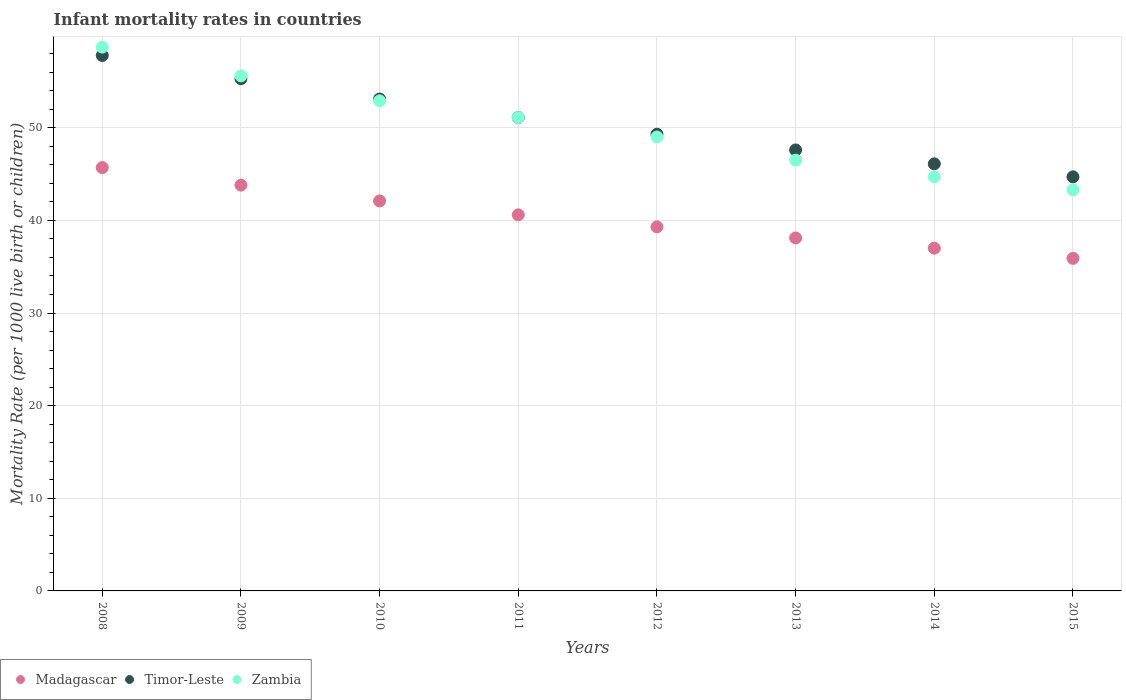How many different coloured dotlines are there?
Keep it short and to the point. 3. Is the number of dotlines equal to the number of legend labels?
Your response must be concise. Yes. What is the infant mortality rate in Timor-Leste in 2012?
Give a very brief answer. 49.3. Across all years, what is the maximum infant mortality rate in Madagascar?
Ensure brevity in your answer.  45.7. Across all years, what is the minimum infant mortality rate in Madagascar?
Offer a terse response. 35.9. In which year was the infant mortality rate in Zambia minimum?
Offer a very short reply. 2015. What is the total infant mortality rate in Timor-Leste in the graph?
Your response must be concise. 405. What is the difference between the infant mortality rate in Zambia in 2012 and that in 2015?
Your answer should be very brief. 5.7. What is the difference between the infant mortality rate in Timor-Leste in 2010 and the infant mortality rate in Madagascar in 2012?
Make the answer very short. 13.8. What is the average infant mortality rate in Zambia per year?
Your answer should be very brief. 50.23. In the year 2010, what is the difference between the infant mortality rate in Zambia and infant mortality rate in Madagascar?
Your answer should be compact. 10.8. In how many years, is the infant mortality rate in Madagascar greater than 14?
Your answer should be compact. 8. What is the ratio of the infant mortality rate in Zambia in 2011 to that in 2012?
Give a very brief answer. 1.04. Is the infant mortality rate in Timor-Leste in 2013 less than that in 2014?
Your answer should be very brief. No. What is the difference between the highest and the lowest infant mortality rate in Madagascar?
Your response must be concise. 9.8. Is the sum of the infant mortality rate in Madagascar in 2008 and 2009 greater than the maximum infant mortality rate in Zambia across all years?
Keep it short and to the point. Yes. Is it the case that in every year, the sum of the infant mortality rate in Timor-Leste and infant mortality rate in Madagascar  is greater than the infant mortality rate in Zambia?
Offer a very short reply. Yes. Does the infant mortality rate in Timor-Leste monotonically increase over the years?
Your answer should be compact. No. Is the infant mortality rate in Zambia strictly greater than the infant mortality rate in Timor-Leste over the years?
Make the answer very short. No. Is the infant mortality rate in Zambia strictly less than the infant mortality rate in Timor-Leste over the years?
Offer a very short reply. No. How many years are there in the graph?
Make the answer very short. 8. What is the difference between two consecutive major ticks on the Y-axis?
Ensure brevity in your answer.  10. Are the values on the major ticks of Y-axis written in scientific E-notation?
Your answer should be compact. No. Does the graph contain any zero values?
Ensure brevity in your answer.  No. Does the graph contain grids?
Give a very brief answer. Yes. How many legend labels are there?
Offer a very short reply. 3. How are the legend labels stacked?
Keep it short and to the point. Horizontal. What is the title of the graph?
Give a very brief answer. Infant mortality rates in countries. What is the label or title of the X-axis?
Your answer should be compact. Years. What is the label or title of the Y-axis?
Your answer should be very brief. Mortality Rate (per 1000 live birth or children). What is the Mortality Rate (per 1000 live birth or children) in Madagascar in 2008?
Give a very brief answer. 45.7. What is the Mortality Rate (per 1000 live birth or children) in Timor-Leste in 2008?
Your answer should be very brief. 57.8. What is the Mortality Rate (per 1000 live birth or children) in Zambia in 2008?
Offer a very short reply. 58.7. What is the Mortality Rate (per 1000 live birth or children) in Madagascar in 2009?
Provide a short and direct response. 43.8. What is the Mortality Rate (per 1000 live birth or children) of Timor-Leste in 2009?
Your response must be concise. 55.3. What is the Mortality Rate (per 1000 live birth or children) of Zambia in 2009?
Offer a terse response. 55.6. What is the Mortality Rate (per 1000 live birth or children) of Madagascar in 2010?
Ensure brevity in your answer.  42.1. What is the Mortality Rate (per 1000 live birth or children) in Timor-Leste in 2010?
Offer a very short reply. 53.1. What is the Mortality Rate (per 1000 live birth or children) of Zambia in 2010?
Offer a terse response. 52.9. What is the Mortality Rate (per 1000 live birth or children) of Madagascar in 2011?
Make the answer very short. 40.6. What is the Mortality Rate (per 1000 live birth or children) in Timor-Leste in 2011?
Your answer should be very brief. 51.1. What is the Mortality Rate (per 1000 live birth or children) in Zambia in 2011?
Keep it short and to the point. 51.1. What is the Mortality Rate (per 1000 live birth or children) in Madagascar in 2012?
Provide a short and direct response. 39.3. What is the Mortality Rate (per 1000 live birth or children) of Timor-Leste in 2012?
Ensure brevity in your answer.  49.3. What is the Mortality Rate (per 1000 live birth or children) in Madagascar in 2013?
Provide a short and direct response. 38.1. What is the Mortality Rate (per 1000 live birth or children) of Timor-Leste in 2013?
Ensure brevity in your answer.  47.6. What is the Mortality Rate (per 1000 live birth or children) in Zambia in 2013?
Provide a short and direct response. 46.5. What is the Mortality Rate (per 1000 live birth or children) of Madagascar in 2014?
Provide a short and direct response. 37. What is the Mortality Rate (per 1000 live birth or children) of Timor-Leste in 2014?
Ensure brevity in your answer.  46.1. What is the Mortality Rate (per 1000 live birth or children) in Zambia in 2014?
Make the answer very short. 44.7. What is the Mortality Rate (per 1000 live birth or children) in Madagascar in 2015?
Make the answer very short. 35.9. What is the Mortality Rate (per 1000 live birth or children) in Timor-Leste in 2015?
Your answer should be compact. 44.7. What is the Mortality Rate (per 1000 live birth or children) of Zambia in 2015?
Make the answer very short. 43.3. Across all years, what is the maximum Mortality Rate (per 1000 live birth or children) in Madagascar?
Your answer should be compact. 45.7. Across all years, what is the maximum Mortality Rate (per 1000 live birth or children) in Timor-Leste?
Offer a very short reply. 57.8. Across all years, what is the maximum Mortality Rate (per 1000 live birth or children) of Zambia?
Provide a short and direct response. 58.7. Across all years, what is the minimum Mortality Rate (per 1000 live birth or children) of Madagascar?
Offer a terse response. 35.9. Across all years, what is the minimum Mortality Rate (per 1000 live birth or children) in Timor-Leste?
Your answer should be compact. 44.7. Across all years, what is the minimum Mortality Rate (per 1000 live birth or children) of Zambia?
Your answer should be very brief. 43.3. What is the total Mortality Rate (per 1000 live birth or children) in Madagascar in the graph?
Give a very brief answer. 322.5. What is the total Mortality Rate (per 1000 live birth or children) in Timor-Leste in the graph?
Offer a very short reply. 405. What is the total Mortality Rate (per 1000 live birth or children) of Zambia in the graph?
Your response must be concise. 401.8. What is the difference between the Mortality Rate (per 1000 live birth or children) of Madagascar in 2008 and that in 2009?
Make the answer very short. 1.9. What is the difference between the Mortality Rate (per 1000 live birth or children) of Timor-Leste in 2008 and that in 2009?
Offer a very short reply. 2.5. What is the difference between the Mortality Rate (per 1000 live birth or children) of Madagascar in 2008 and that in 2010?
Provide a succinct answer. 3.6. What is the difference between the Mortality Rate (per 1000 live birth or children) of Madagascar in 2008 and that in 2013?
Your response must be concise. 7.6. What is the difference between the Mortality Rate (per 1000 live birth or children) of Zambia in 2008 and that in 2014?
Your response must be concise. 14. What is the difference between the Mortality Rate (per 1000 live birth or children) in Madagascar in 2009 and that in 2010?
Your response must be concise. 1.7. What is the difference between the Mortality Rate (per 1000 live birth or children) in Madagascar in 2009 and that in 2011?
Provide a short and direct response. 3.2. What is the difference between the Mortality Rate (per 1000 live birth or children) in Madagascar in 2009 and that in 2012?
Keep it short and to the point. 4.5. What is the difference between the Mortality Rate (per 1000 live birth or children) of Timor-Leste in 2009 and that in 2012?
Make the answer very short. 6. What is the difference between the Mortality Rate (per 1000 live birth or children) in Zambia in 2009 and that in 2013?
Offer a terse response. 9.1. What is the difference between the Mortality Rate (per 1000 live birth or children) in Madagascar in 2009 and that in 2014?
Keep it short and to the point. 6.8. What is the difference between the Mortality Rate (per 1000 live birth or children) in Timor-Leste in 2009 and that in 2014?
Your response must be concise. 9.2. What is the difference between the Mortality Rate (per 1000 live birth or children) of Timor-Leste in 2009 and that in 2015?
Your answer should be compact. 10.6. What is the difference between the Mortality Rate (per 1000 live birth or children) in Zambia in 2009 and that in 2015?
Make the answer very short. 12.3. What is the difference between the Mortality Rate (per 1000 live birth or children) in Zambia in 2010 and that in 2011?
Your response must be concise. 1.8. What is the difference between the Mortality Rate (per 1000 live birth or children) of Madagascar in 2010 and that in 2012?
Offer a terse response. 2.8. What is the difference between the Mortality Rate (per 1000 live birth or children) in Timor-Leste in 2010 and that in 2012?
Provide a short and direct response. 3.8. What is the difference between the Mortality Rate (per 1000 live birth or children) of Zambia in 2010 and that in 2012?
Ensure brevity in your answer.  3.9. What is the difference between the Mortality Rate (per 1000 live birth or children) in Zambia in 2010 and that in 2013?
Your answer should be very brief. 6.4. What is the difference between the Mortality Rate (per 1000 live birth or children) of Madagascar in 2010 and that in 2015?
Give a very brief answer. 6.2. What is the difference between the Mortality Rate (per 1000 live birth or children) in Zambia in 2010 and that in 2015?
Provide a short and direct response. 9.6. What is the difference between the Mortality Rate (per 1000 live birth or children) in Madagascar in 2011 and that in 2012?
Provide a succinct answer. 1.3. What is the difference between the Mortality Rate (per 1000 live birth or children) of Zambia in 2011 and that in 2012?
Provide a short and direct response. 2.1. What is the difference between the Mortality Rate (per 1000 live birth or children) in Timor-Leste in 2011 and that in 2013?
Give a very brief answer. 3.5. What is the difference between the Mortality Rate (per 1000 live birth or children) in Madagascar in 2011 and that in 2014?
Provide a succinct answer. 3.6. What is the difference between the Mortality Rate (per 1000 live birth or children) in Zambia in 2011 and that in 2014?
Your answer should be very brief. 6.4. What is the difference between the Mortality Rate (per 1000 live birth or children) in Madagascar in 2011 and that in 2015?
Your answer should be compact. 4.7. What is the difference between the Mortality Rate (per 1000 live birth or children) of Timor-Leste in 2011 and that in 2015?
Offer a terse response. 6.4. What is the difference between the Mortality Rate (per 1000 live birth or children) of Zambia in 2011 and that in 2015?
Offer a very short reply. 7.8. What is the difference between the Mortality Rate (per 1000 live birth or children) in Zambia in 2012 and that in 2013?
Offer a very short reply. 2.5. What is the difference between the Mortality Rate (per 1000 live birth or children) in Madagascar in 2012 and that in 2014?
Give a very brief answer. 2.3. What is the difference between the Mortality Rate (per 1000 live birth or children) of Timor-Leste in 2012 and that in 2014?
Offer a very short reply. 3.2. What is the difference between the Mortality Rate (per 1000 live birth or children) of Timor-Leste in 2013 and that in 2014?
Provide a short and direct response. 1.5. What is the difference between the Mortality Rate (per 1000 live birth or children) of Timor-Leste in 2013 and that in 2015?
Your response must be concise. 2.9. What is the difference between the Mortality Rate (per 1000 live birth or children) of Zambia in 2013 and that in 2015?
Provide a succinct answer. 3.2. What is the difference between the Mortality Rate (per 1000 live birth or children) in Madagascar in 2014 and that in 2015?
Give a very brief answer. 1.1. What is the difference between the Mortality Rate (per 1000 live birth or children) of Timor-Leste in 2014 and that in 2015?
Keep it short and to the point. 1.4. What is the difference between the Mortality Rate (per 1000 live birth or children) in Zambia in 2014 and that in 2015?
Your answer should be very brief. 1.4. What is the difference between the Mortality Rate (per 1000 live birth or children) of Madagascar in 2008 and the Mortality Rate (per 1000 live birth or children) of Zambia in 2009?
Provide a succinct answer. -9.9. What is the difference between the Mortality Rate (per 1000 live birth or children) of Timor-Leste in 2008 and the Mortality Rate (per 1000 live birth or children) of Zambia in 2009?
Give a very brief answer. 2.2. What is the difference between the Mortality Rate (per 1000 live birth or children) of Madagascar in 2008 and the Mortality Rate (per 1000 live birth or children) of Timor-Leste in 2010?
Give a very brief answer. -7.4. What is the difference between the Mortality Rate (per 1000 live birth or children) in Madagascar in 2008 and the Mortality Rate (per 1000 live birth or children) in Zambia in 2010?
Offer a very short reply. -7.2. What is the difference between the Mortality Rate (per 1000 live birth or children) in Madagascar in 2008 and the Mortality Rate (per 1000 live birth or children) in Timor-Leste in 2011?
Offer a very short reply. -5.4. What is the difference between the Mortality Rate (per 1000 live birth or children) in Timor-Leste in 2008 and the Mortality Rate (per 1000 live birth or children) in Zambia in 2011?
Ensure brevity in your answer.  6.7. What is the difference between the Mortality Rate (per 1000 live birth or children) of Madagascar in 2008 and the Mortality Rate (per 1000 live birth or children) of Zambia in 2012?
Offer a terse response. -3.3. What is the difference between the Mortality Rate (per 1000 live birth or children) of Madagascar in 2008 and the Mortality Rate (per 1000 live birth or children) of Timor-Leste in 2013?
Your answer should be very brief. -1.9. What is the difference between the Mortality Rate (per 1000 live birth or children) in Timor-Leste in 2008 and the Mortality Rate (per 1000 live birth or children) in Zambia in 2013?
Your response must be concise. 11.3. What is the difference between the Mortality Rate (per 1000 live birth or children) in Madagascar in 2008 and the Mortality Rate (per 1000 live birth or children) in Timor-Leste in 2014?
Your answer should be compact. -0.4. What is the difference between the Mortality Rate (per 1000 live birth or children) of Timor-Leste in 2008 and the Mortality Rate (per 1000 live birth or children) of Zambia in 2014?
Your response must be concise. 13.1. What is the difference between the Mortality Rate (per 1000 live birth or children) in Madagascar in 2008 and the Mortality Rate (per 1000 live birth or children) in Zambia in 2015?
Your answer should be compact. 2.4. What is the difference between the Mortality Rate (per 1000 live birth or children) in Madagascar in 2009 and the Mortality Rate (per 1000 live birth or children) in Zambia in 2010?
Make the answer very short. -9.1. What is the difference between the Mortality Rate (per 1000 live birth or children) in Timor-Leste in 2009 and the Mortality Rate (per 1000 live birth or children) in Zambia in 2010?
Give a very brief answer. 2.4. What is the difference between the Mortality Rate (per 1000 live birth or children) of Madagascar in 2009 and the Mortality Rate (per 1000 live birth or children) of Zambia in 2011?
Give a very brief answer. -7.3. What is the difference between the Mortality Rate (per 1000 live birth or children) of Timor-Leste in 2009 and the Mortality Rate (per 1000 live birth or children) of Zambia in 2011?
Provide a succinct answer. 4.2. What is the difference between the Mortality Rate (per 1000 live birth or children) in Madagascar in 2009 and the Mortality Rate (per 1000 live birth or children) in Timor-Leste in 2013?
Offer a terse response. -3.8. What is the difference between the Mortality Rate (per 1000 live birth or children) in Madagascar in 2009 and the Mortality Rate (per 1000 live birth or children) in Zambia in 2013?
Offer a terse response. -2.7. What is the difference between the Mortality Rate (per 1000 live birth or children) in Timor-Leste in 2009 and the Mortality Rate (per 1000 live birth or children) in Zambia in 2013?
Your answer should be very brief. 8.8. What is the difference between the Mortality Rate (per 1000 live birth or children) in Madagascar in 2009 and the Mortality Rate (per 1000 live birth or children) in Timor-Leste in 2014?
Your answer should be compact. -2.3. What is the difference between the Mortality Rate (per 1000 live birth or children) in Timor-Leste in 2009 and the Mortality Rate (per 1000 live birth or children) in Zambia in 2014?
Offer a terse response. 10.6. What is the difference between the Mortality Rate (per 1000 live birth or children) in Madagascar in 2009 and the Mortality Rate (per 1000 live birth or children) in Timor-Leste in 2015?
Provide a succinct answer. -0.9. What is the difference between the Mortality Rate (per 1000 live birth or children) in Madagascar in 2010 and the Mortality Rate (per 1000 live birth or children) in Timor-Leste in 2011?
Your response must be concise. -9. What is the difference between the Mortality Rate (per 1000 live birth or children) in Timor-Leste in 2010 and the Mortality Rate (per 1000 live birth or children) in Zambia in 2011?
Ensure brevity in your answer.  2. What is the difference between the Mortality Rate (per 1000 live birth or children) of Madagascar in 2010 and the Mortality Rate (per 1000 live birth or children) of Zambia in 2012?
Your answer should be compact. -6.9. What is the difference between the Mortality Rate (per 1000 live birth or children) in Madagascar in 2010 and the Mortality Rate (per 1000 live birth or children) in Zambia in 2013?
Ensure brevity in your answer.  -4.4. What is the difference between the Mortality Rate (per 1000 live birth or children) of Timor-Leste in 2010 and the Mortality Rate (per 1000 live birth or children) of Zambia in 2013?
Offer a terse response. 6.6. What is the difference between the Mortality Rate (per 1000 live birth or children) in Madagascar in 2010 and the Mortality Rate (per 1000 live birth or children) in Timor-Leste in 2014?
Your answer should be very brief. -4. What is the difference between the Mortality Rate (per 1000 live birth or children) in Madagascar in 2010 and the Mortality Rate (per 1000 live birth or children) in Zambia in 2014?
Offer a very short reply. -2.6. What is the difference between the Mortality Rate (per 1000 live birth or children) in Timor-Leste in 2010 and the Mortality Rate (per 1000 live birth or children) in Zambia in 2014?
Provide a short and direct response. 8.4. What is the difference between the Mortality Rate (per 1000 live birth or children) in Timor-Leste in 2011 and the Mortality Rate (per 1000 live birth or children) in Zambia in 2013?
Offer a very short reply. 4.6. What is the difference between the Mortality Rate (per 1000 live birth or children) of Madagascar in 2011 and the Mortality Rate (per 1000 live birth or children) of Zambia in 2014?
Offer a very short reply. -4.1. What is the difference between the Mortality Rate (per 1000 live birth or children) of Timor-Leste in 2011 and the Mortality Rate (per 1000 live birth or children) of Zambia in 2014?
Provide a short and direct response. 6.4. What is the difference between the Mortality Rate (per 1000 live birth or children) of Madagascar in 2012 and the Mortality Rate (per 1000 live birth or children) of Timor-Leste in 2013?
Offer a terse response. -8.3. What is the difference between the Mortality Rate (per 1000 live birth or children) in Madagascar in 2012 and the Mortality Rate (per 1000 live birth or children) in Zambia in 2013?
Offer a terse response. -7.2. What is the difference between the Mortality Rate (per 1000 live birth or children) of Timor-Leste in 2012 and the Mortality Rate (per 1000 live birth or children) of Zambia in 2013?
Make the answer very short. 2.8. What is the difference between the Mortality Rate (per 1000 live birth or children) of Timor-Leste in 2012 and the Mortality Rate (per 1000 live birth or children) of Zambia in 2014?
Offer a very short reply. 4.6. What is the difference between the Mortality Rate (per 1000 live birth or children) of Madagascar in 2012 and the Mortality Rate (per 1000 live birth or children) of Timor-Leste in 2015?
Give a very brief answer. -5.4. What is the difference between the Mortality Rate (per 1000 live birth or children) in Madagascar in 2013 and the Mortality Rate (per 1000 live birth or children) in Timor-Leste in 2014?
Provide a succinct answer. -8. What is the difference between the Mortality Rate (per 1000 live birth or children) in Madagascar in 2013 and the Mortality Rate (per 1000 live birth or children) in Timor-Leste in 2015?
Your answer should be compact. -6.6. What is the average Mortality Rate (per 1000 live birth or children) in Madagascar per year?
Ensure brevity in your answer.  40.31. What is the average Mortality Rate (per 1000 live birth or children) in Timor-Leste per year?
Keep it short and to the point. 50.62. What is the average Mortality Rate (per 1000 live birth or children) in Zambia per year?
Ensure brevity in your answer.  50.23. In the year 2009, what is the difference between the Mortality Rate (per 1000 live birth or children) of Madagascar and Mortality Rate (per 1000 live birth or children) of Timor-Leste?
Provide a short and direct response. -11.5. In the year 2009, what is the difference between the Mortality Rate (per 1000 live birth or children) in Madagascar and Mortality Rate (per 1000 live birth or children) in Zambia?
Your answer should be very brief. -11.8. In the year 2010, what is the difference between the Mortality Rate (per 1000 live birth or children) of Madagascar and Mortality Rate (per 1000 live birth or children) of Timor-Leste?
Your answer should be compact. -11. In the year 2010, what is the difference between the Mortality Rate (per 1000 live birth or children) of Madagascar and Mortality Rate (per 1000 live birth or children) of Zambia?
Your response must be concise. -10.8. In the year 2010, what is the difference between the Mortality Rate (per 1000 live birth or children) of Timor-Leste and Mortality Rate (per 1000 live birth or children) of Zambia?
Provide a short and direct response. 0.2. In the year 2011, what is the difference between the Mortality Rate (per 1000 live birth or children) of Madagascar and Mortality Rate (per 1000 live birth or children) of Zambia?
Give a very brief answer. -10.5. In the year 2011, what is the difference between the Mortality Rate (per 1000 live birth or children) in Timor-Leste and Mortality Rate (per 1000 live birth or children) in Zambia?
Give a very brief answer. 0. In the year 2013, what is the difference between the Mortality Rate (per 1000 live birth or children) of Madagascar and Mortality Rate (per 1000 live birth or children) of Zambia?
Offer a terse response. -8.4. In the year 2013, what is the difference between the Mortality Rate (per 1000 live birth or children) of Timor-Leste and Mortality Rate (per 1000 live birth or children) of Zambia?
Offer a very short reply. 1.1. In the year 2014, what is the difference between the Mortality Rate (per 1000 live birth or children) in Madagascar and Mortality Rate (per 1000 live birth or children) in Timor-Leste?
Provide a short and direct response. -9.1. In the year 2014, what is the difference between the Mortality Rate (per 1000 live birth or children) in Madagascar and Mortality Rate (per 1000 live birth or children) in Zambia?
Your answer should be compact. -7.7. In the year 2014, what is the difference between the Mortality Rate (per 1000 live birth or children) of Timor-Leste and Mortality Rate (per 1000 live birth or children) of Zambia?
Provide a succinct answer. 1.4. In the year 2015, what is the difference between the Mortality Rate (per 1000 live birth or children) of Madagascar and Mortality Rate (per 1000 live birth or children) of Zambia?
Your answer should be compact. -7.4. In the year 2015, what is the difference between the Mortality Rate (per 1000 live birth or children) in Timor-Leste and Mortality Rate (per 1000 live birth or children) in Zambia?
Provide a short and direct response. 1.4. What is the ratio of the Mortality Rate (per 1000 live birth or children) of Madagascar in 2008 to that in 2009?
Offer a very short reply. 1.04. What is the ratio of the Mortality Rate (per 1000 live birth or children) of Timor-Leste in 2008 to that in 2009?
Your response must be concise. 1.05. What is the ratio of the Mortality Rate (per 1000 live birth or children) in Zambia in 2008 to that in 2009?
Your answer should be compact. 1.06. What is the ratio of the Mortality Rate (per 1000 live birth or children) in Madagascar in 2008 to that in 2010?
Offer a terse response. 1.09. What is the ratio of the Mortality Rate (per 1000 live birth or children) in Timor-Leste in 2008 to that in 2010?
Your answer should be compact. 1.09. What is the ratio of the Mortality Rate (per 1000 live birth or children) of Zambia in 2008 to that in 2010?
Offer a very short reply. 1.11. What is the ratio of the Mortality Rate (per 1000 live birth or children) in Madagascar in 2008 to that in 2011?
Keep it short and to the point. 1.13. What is the ratio of the Mortality Rate (per 1000 live birth or children) of Timor-Leste in 2008 to that in 2011?
Make the answer very short. 1.13. What is the ratio of the Mortality Rate (per 1000 live birth or children) in Zambia in 2008 to that in 2011?
Your response must be concise. 1.15. What is the ratio of the Mortality Rate (per 1000 live birth or children) in Madagascar in 2008 to that in 2012?
Your response must be concise. 1.16. What is the ratio of the Mortality Rate (per 1000 live birth or children) of Timor-Leste in 2008 to that in 2012?
Offer a terse response. 1.17. What is the ratio of the Mortality Rate (per 1000 live birth or children) in Zambia in 2008 to that in 2012?
Keep it short and to the point. 1.2. What is the ratio of the Mortality Rate (per 1000 live birth or children) in Madagascar in 2008 to that in 2013?
Provide a succinct answer. 1.2. What is the ratio of the Mortality Rate (per 1000 live birth or children) in Timor-Leste in 2008 to that in 2013?
Provide a succinct answer. 1.21. What is the ratio of the Mortality Rate (per 1000 live birth or children) of Zambia in 2008 to that in 2013?
Keep it short and to the point. 1.26. What is the ratio of the Mortality Rate (per 1000 live birth or children) of Madagascar in 2008 to that in 2014?
Provide a short and direct response. 1.24. What is the ratio of the Mortality Rate (per 1000 live birth or children) of Timor-Leste in 2008 to that in 2014?
Provide a succinct answer. 1.25. What is the ratio of the Mortality Rate (per 1000 live birth or children) in Zambia in 2008 to that in 2014?
Offer a very short reply. 1.31. What is the ratio of the Mortality Rate (per 1000 live birth or children) of Madagascar in 2008 to that in 2015?
Make the answer very short. 1.27. What is the ratio of the Mortality Rate (per 1000 live birth or children) in Timor-Leste in 2008 to that in 2015?
Your response must be concise. 1.29. What is the ratio of the Mortality Rate (per 1000 live birth or children) of Zambia in 2008 to that in 2015?
Keep it short and to the point. 1.36. What is the ratio of the Mortality Rate (per 1000 live birth or children) of Madagascar in 2009 to that in 2010?
Ensure brevity in your answer.  1.04. What is the ratio of the Mortality Rate (per 1000 live birth or children) of Timor-Leste in 2009 to that in 2010?
Provide a succinct answer. 1.04. What is the ratio of the Mortality Rate (per 1000 live birth or children) of Zambia in 2009 to that in 2010?
Keep it short and to the point. 1.05. What is the ratio of the Mortality Rate (per 1000 live birth or children) in Madagascar in 2009 to that in 2011?
Offer a terse response. 1.08. What is the ratio of the Mortality Rate (per 1000 live birth or children) of Timor-Leste in 2009 to that in 2011?
Make the answer very short. 1.08. What is the ratio of the Mortality Rate (per 1000 live birth or children) in Zambia in 2009 to that in 2011?
Give a very brief answer. 1.09. What is the ratio of the Mortality Rate (per 1000 live birth or children) of Madagascar in 2009 to that in 2012?
Provide a short and direct response. 1.11. What is the ratio of the Mortality Rate (per 1000 live birth or children) of Timor-Leste in 2009 to that in 2012?
Your response must be concise. 1.12. What is the ratio of the Mortality Rate (per 1000 live birth or children) in Zambia in 2009 to that in 2012?
Provide a short and direct response. 1.13. What is the ratio of the Mortality Rate (per 1000 live birth or children) of Madagascar in 2009 to that in 2013?
Give a very brief answer. 1.15. What is the ratio of the Mortality Rate (per 1000 live birth or children) of Timor-Leste in 2009 to that in 2013?
Offer a terse response. 1.16. What is the ratio of the Mortality Rate (per 1000 live birth or children) in Zambia in 2009 to that in 2013?
Ensure brevity in your answer.  1.2. What is the ratio of the Mortality Rate (per 1000 live birth or children) of Madagascar in 2009 to that in 2014?
Your response must be concise. 1.18. What is the ratio of the Mortality Rate (per 1000 live birth or children) of Timor-Leste in 2009 to that in 2014?
Make the answer very short. 1.2. What is the ratio of the Mortality Rate (per 1000 live birth or children) in Zambia in 2009 to that in 2014?
Provide a succinct answer. 1.24. What is the ratio of the Mortality Rate (per 1000 live birth or children) in Madagascar in 2009 to that in 2015?
Your answer should be compact. 1.22. What is the ratio of the Mortality Rate (per 1000 live birth or children) of Timor-Leste in 2009 to that in 2015?
Offer a very short reply. 1.24. What is the ratio of the Mortality Rate (per 1000 live birth or children) of Zambia in 2009 to that in 2015?
Keep it short and to the point. 1.28. What is the ratio of the Mortality Rate (per 1000 live birth or children) in Madagascar in 2010 to that in 2011?
Offer a very short reply. 1.04. What is the ratio of the Mortality Rate (per 1000 live birth or children) of Timor-Leste in 2010 to that in 2011?
Ensure brevity in your answer.  1.04. What is the ratio of the Mortality Rate (per 1000 live birth or children) in Zambia in 2010 to that in 2011?
Offer a terse response. 1.04. What is the ratio of the Mortality Rate (per 1000 live birth or children) of Madagascar in 2010 to that in 2012?
Your response must be concise. 1.07. What is the ratio of the Mortality Rate (per 1000 live birth or children) of Timor-Leste in 2010 to that in 2012?
Offer a very short reply. 1.08. What is the ratio of the Mortality Rate (per 1000 live birth or children) in Zambia in 2010 to that in 2012?
Offer a terse response. 1.08. What is the ratio of the Mortality Rate (per 1000 live birth or children) in Madagascar in 2010 to that in 2013?
Give a very brief answer. 1.1. What is the ratio of the Mortality Rate (per 1000 live birth or children) in Timor-Leste in 2010 to that in 2013?
Offer a terse response. 1.12. What is the ratio of the Mortality Rate (per 1000 live birth or children) in Zambia in 2010 to that in 2013?
Offer a very short reply. 1.14. What is the ratio of the Mortality Rate (per 1000 live birth or children) in Madagascar in 2010 to that in 2014?
Provide a succinct answer. 1.14. What is the ratio of the Mortality Rate (per 1000 live birth or children) of Timor-Leste in 2010 to that in 2014?
Give a very brief answer. 1.15. What is the ratio of the Mortality Rate (per 1000 live birth or children) in Zambia in 2010 to that in 2014?
Keep it short and to the point. 1.18. What is the ratio of the Mortality Rate (per 1000 live birth or children) in Madagascar in 2010 to that in 2015?
Your response must be concise. 1.17. What is the ratio of the Mortality Rate (per 1000 live birth or children) in Timor-Leste in 2010 to that in 2015?
Make the answer very short. 1.19. What is the ratio of the Mortality Rate (per 1000 live birth or children) of Zambia in 2010 to that in 2015?
Provide a short and direct response. 1.22. What is the ratio of the Mortality Rate (per 1000 live birth or children) in Madagascar in 2011 to that in 2012?
Your answer should be compact. 1.03. What is the ratio of the Mortality Rate (per 1000 live birth or children) of Timor-Leste in 2011 to that in 2012?
Give a very brief answer. 1.04. What is the ratio of the Mortality Rate (per 1000 live birth or children) in Zambia in 2011 to that in 2012?
Keep it short and to the point. 1.04. What is the ratio of the Mortality Rate (per 1000 live birth or children) in Madagascar in 2011 to that in 2013?
Your answer should be compact. 1.07. What is the ratio of the Mortality Rate (per 1000 live birth or children) of Timor-Leste in 2011 to that in 2013?
Your response must be concise. 1.07. What is the ratio of the Mortality Rate (per 1000 live birth or children) in Zambia in 2011 to that in 2013?
Your answer should be compact. 1.1. What is the ratio of the Mortality Rate (per 1000 live birth or children) of Madagascar in 2011 to that in 2014?
Provide a short and direct response. 1.1. What is the ratio of the Mortality Rate (per 1000 live birth or children) in Timor-Leste in 2011 to that in 2014?
Offer a very short reply. 1.11. What is the ratio of the Mortality Rate (per 1000 live birth or children) of Zambia in 2011 to that in 2014?
Your answer should be very brief. 1.14. What is the ratio of the Mortality Rate (per 1000 live birth or children) of Madagascar in 2011 to that in 2015?
Provide a short and direct response. 1.13. What is the ratio of the Mortality Rate (per 1000 live birth or children) of Timor-Leste in 2011 to that in 2015?
Provide a succinct answer. 1.14. What is the ratio of the Mortality Rate (per 1000 live birth or children) of Zambia in 2011 to that in 2015?
Give a very brief answer. 1.18. What is the ratio of the Mortality Rate (per 1000 live birth or children) of Madagascar in 2012 to that in 2013?
Ensure brevity in your answer.  1.03. What is the ratio of the Mortality Rate (per 1000 live birth or children) of Timor-Leste in 2012 to that in 2013?
Give a very brief answer. 1.04. What is the ratio of the Mortality Rate (per 1000 live birth or children) in Zambia in 2012 to that in 2013?
Your answer should be compact. 1.05. What is the ratio of the Mortality Rate (per 1000 live birth or children) in Madagascar in 2012 to that in 2014?
Keep it short and to the point. 1.06. What is the ratio of the Mortality Rate (per 1000 live birth or children) of Timor-Leste in 2012 to that in 2014?
Offer a very short reply. 1.07. What is the ratio of the Mortality Rate (per 1000 live birth or children) of Zambia in 2012 to that in 2014?
Give a very brief answer. 1.1. What is the ratio of the Mortality Rate (per 1000 live birth or children) in Madagascar in 2012 to that in 2015?
Keep it short and to the point. 1.09. What is the ratio of the Mortality Rate (per 1000 live birth or children) in Timor-Leste in 2012 to that in 2015?
Ensure brevity in your answer.  1.1. What is the ratio of the Mortality Rate (per 1000 live birth or children) of Zambia in 2012 to that in 2015?
Provide a short and direct response. 1.13. What is the ratio of the Mortality Rate (per 1000 live birth or children) of Madagascar in 2013 to that in 2014?
Keep it short and to the point. 1.03. What is the ratio of the Mortality Rate (per 1000 live birth or children) in Timor-Leste in 2013 to that in 2014?
Offer a very short reply. 1.03. What is the ratio of the Mortality Rate (per 1000 live birth or children) in Zambia in 2013 to that in 2014?
Keep it short and to the point. 1.04. What is the ratio of the Mortality Rate (per 1000 live birth or children) in Madagascar in 2013 to that in 2015?
Make the answer very short. 1.06. What is the ratio of the Mortality Rate (per 1000 live birth or children) of Timor-Leste in 2013 to that in 2015?
Offer a very short reply. 1.06. What is the ratio of the Mortality Rate (per 1000 live birth or children) in Zambia in 2013 to that in 2015?
Your answer should be very brief. 1.07. What is the ratio of the Mortality Rate (per 1000 live birth or children) of Madagascar in 2014 to that in 2015?
Ensure brevity in your answer.  1.03. What is the ratio of the Mortality Rate (per 1000 live birth or children) in Timor-Leste in 2014 to that in 2015?
Keep it short and to the point. 1.03. What is the ratio of the Mortality Rate (per 1000 live birth or children) of Zambia in 2014 to that in 2015?
Provide a short and direct response. 1.03. What is the difference between the highest and the second highest Mortality Rate (per 1000 live birth or children) of Zambia?
Offer a very short reply. 3.1. 